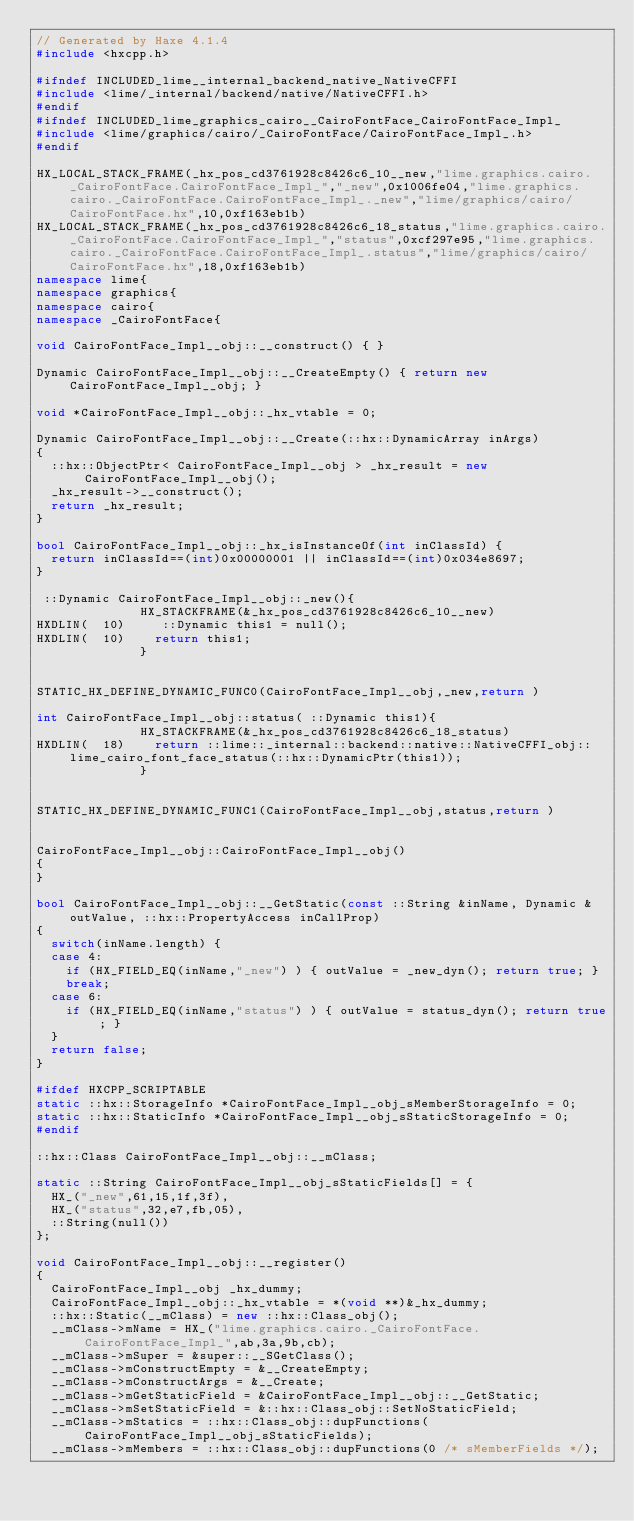<code> <loc_0><loc_0><loc_500><loc_500><_C++_>// Generated by Haxe 4.1.4
#include <hxcpp.h>

#ifndef INCLUDED_lime__internal_backend_native_NativeCFFI
#include <lime/_internal/backend/native/NativeCFFI.h>
#endif
#ifndef INCLUDED_lime_graphics_cairo__CairoFontFace_CairoFontFace_Impl_
#include <lime/graphics/cairo/_CairoFontFace/CairoFontFace_Impl_.h>
#endif

HX_LOCAL_STACK_FRAME(_hx_pos_cd3761928c8426c6_10__new,"lime.graphics.cairo._CairoFontFace.CairoFontFace_Impl_","_new",0x1006fe04,"lime.graphics.cairo._CairoFontFace.CairoFontFace_Impl_._new","lime/graphics/cairo/CairoFontFace.hx",10,0xf163eb1b)
HX_LOCAL_STACK_FRAME(_hx_pos_cd3761928c8426c6_18_status,"lime.graphics.cairo._CairoFontFace.CairoFontFace_Impl_","status",0xcf297e95,"lime.graphics.cairo._CairoFontFace.CairoFontFace_Impl_.status","lime/graphics/cairo/CairoFontFace.hx",18,0xf163eb1b)
namespace lime{
namespace graphics{
namespace cairo{
namespace _CairoFontFace{

void CairoFontFace_Impl__obj::__construct() { }

Dynamic CairoFontFace_Impl__obj::__CreateEmpty() { return new CairoFontFace_Impl__obj; }

void *CairoFontFace_Impl__obj::_hx_vtable = 0;

Dynamic CairoFontFace_Impl__obj::__Create(::hx::DynamicArray inArgs)
{
	::hx::ObjectPtr< CairoFontFace_Impl__obj > _hx_result = new CairoFontFace_Impl__obj();
	_hx_result->__construct();
	return _hx_result;
}

bool CairoFontFace_Impl__obj::_hx_isInstanceOf(int inClassId) {
	return inClassId==(int)0x00000001 || inClassId==(int)0x034e8697;
}

 ::Dynamic CairoFontFace_Impl__obj::_new(){
            	HX_STACKFRAME(&_hx_pos_cd3761928c8426c6_10__new)
HXDLIN(  10)		 ::Dynamic this1 = null();
HXDLIN(  10)		return this1;
            	}


STATIC_HX_DEFINE_DYNAMIC_FUNC0(CairoFontFace_Impl__obj,_new,return )

int CairoFontFace_Impl__obj::status( ::Dynamic this1){
            	HX_STACKFRAME(&_hx_pos_cd3761928c8426c6_18_status)
HXDLIN(  18)		return ::lime::_internal::backend::native::NativeCFFI_obj::lime_cairo_font_face_status(::hx::DynamicPtr(this1));
            	}


STATIC_HX_DEFINE_DYNAMIC_FUNC1(CairoFontFace_Impl__obj,status,return )


CairoFontFace_Impl__obj::CairoFontFace_Impl__obj()
{
}

bool CairoFontFace_Impl__obj::__GetStatic(const ::String &inName, Dynamic &outValue, ::hx::PropertyAccess inCallProp)
{
	switch(inName.length) {
	case 4:
		if (HX_FIELD_EQ(inName,"_new") ) { outValue = _new_dyn(); return true; }
		break;
	case 6:
		if (HX_FIELD_EQ(inName,"status") ) { outValue = status_dyn(); return true; }
	}
	return false;
}

#ifdef HXCPP_SCRIPTABLE
static ::hx::StorageInfo *CairoFontFace_Impl__obj_sMemberStorageInfo = 0;
static ::hx::StaticInfo *CairoFontFace_Impl__obj_sStaticStorageInfo = 0;
#endif

::hx::Class CairoFontFace_Impl__obj::__mClass;

static ::String CairoFontFace_Impl__obj_sStaticFields[] = {
	HX_("_new",61,15,1f,3f),
	HX_("status",32,e7,fb,05),
	::String(null())
};

void CairoFontFace_Impl__obj::__register()
{
	CairoFontFace_Impl__obj _hx_dummy;
	CairoFontFace_Impl__obj::_hx_vtable = *(void **)&_hx_dummy;
	::hx::Static(__mClass) = new ::hx::Class_obj();
	__mClass->mName = HX_("lime.graphics.cairo._CairoFontFace.CairoFontFace_Impl_",ab,3a,9b,cb);
	__mClass->mSuper = &super::__SGetClass();
	__mClass->mConstructEmpty = &__CreateEmpty;
	__mClass->mConstructArgs = &__Create;
	__mClass->mGetStaticField = &CairoFontFace_Impl__obj::__GetStatic;
	__mClass->mSetStaticField = &::hx::Class_obj::SetNoStaticField;
	__mClass->mStatics = ::hx::Class_obj::dupFunctions(CairoFontFace_Impl__obj_sStaticFields);
	__mClass->mMembers = ::hx::Class_obj::dupFunctions(0 /* sMemberFields */);</code> 